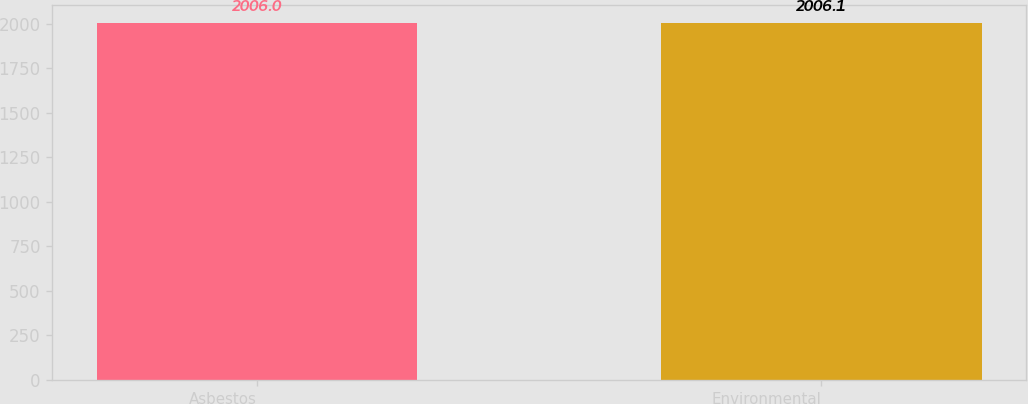Convert chart to OTSL. <chart><loc_0><loc_0><loc_500><loc_500><bar_chart><fcel>Asbestos<fcel>Environmental<nl><fcel>2006<fcel>2006.1<nl></chart> 